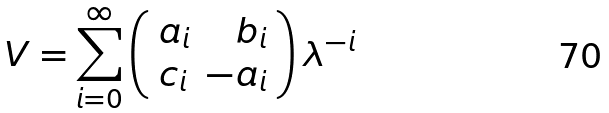Convert formula to latex. <formula><loc_0><loc_0><loc_500><loc_500>V = \sum _ { i = 0 } ^ { \infty } \left ( \begin{array} { l r } a _ { i } & b _ { i } \\ c _ { i } & - a _ { i } \end{array} \right ) \lambda ^ { - i }</formula> 